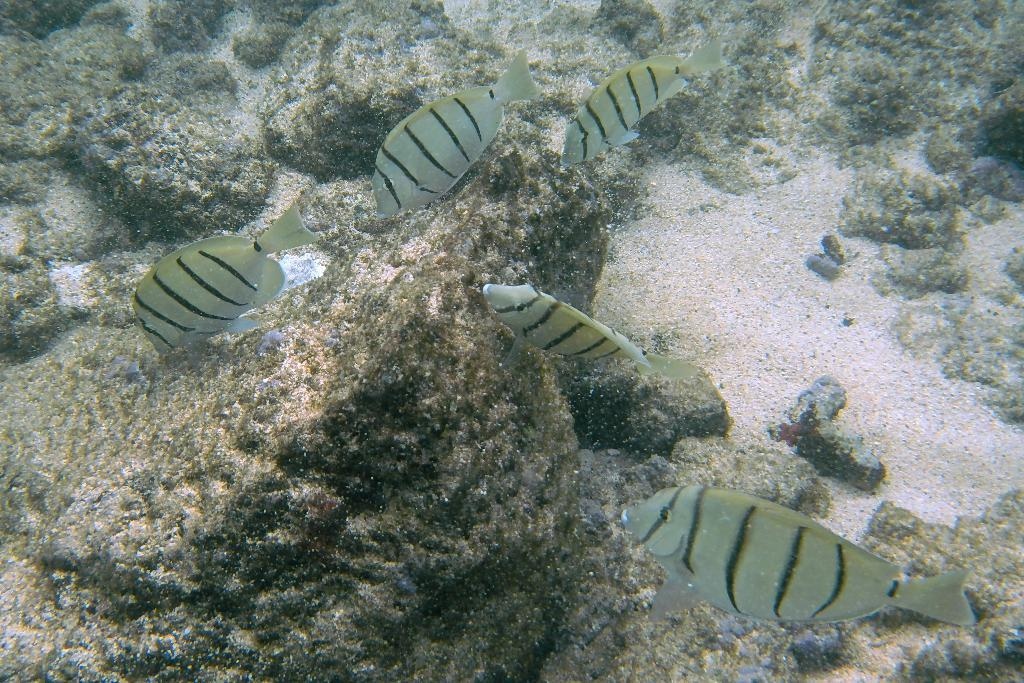What type of animals can be seen in the water in the image? There are fishes in the water in the image. What other elements can be seen in the image besides the water? There are rocks and sand visible in the image. How many boys are wishing for a number in the image? There are no boys or numbers present in the image; it features fishes in the water, rocks, and sand. 